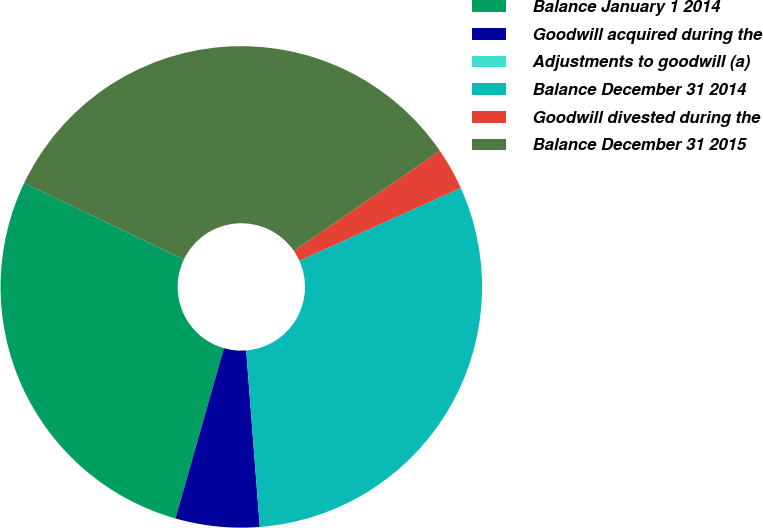Convert chart. <chart><loc_0><loc_0><loc_500><loc_500><pie_chart><fcel>Balance January 1 2014<fcel>Goodwill acquired during the<fcel>Adjustments to goodwill (a)<fcel>Balance December 31 2014<fcel>Goodwill divested during the<fcel>Balance December 31 2015<nl><fcel>27.7%<fcel>5.63%<fcel>0.0%<fcel>30.52%<fcel>2.82%<fcel>33.33%<nl></chart> 